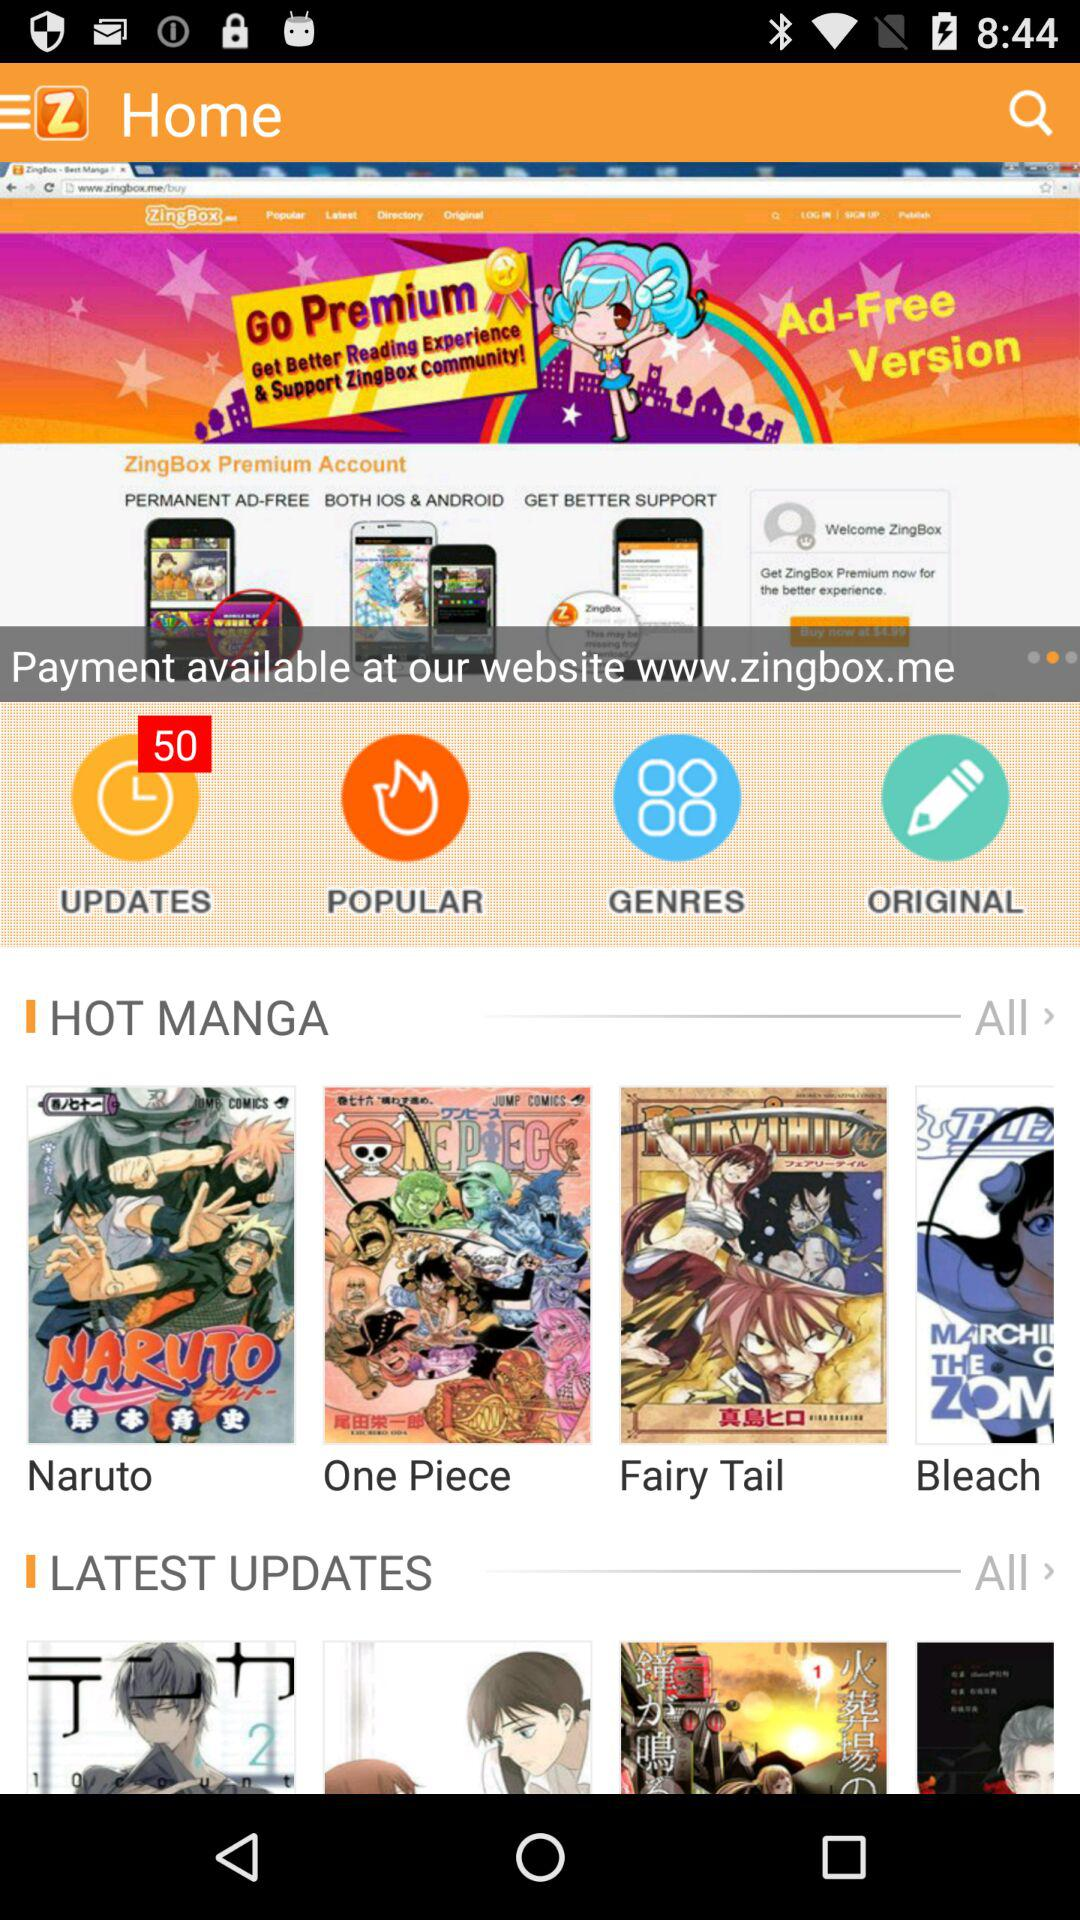What is the name of the application? The name of the application is "ZingBox". 